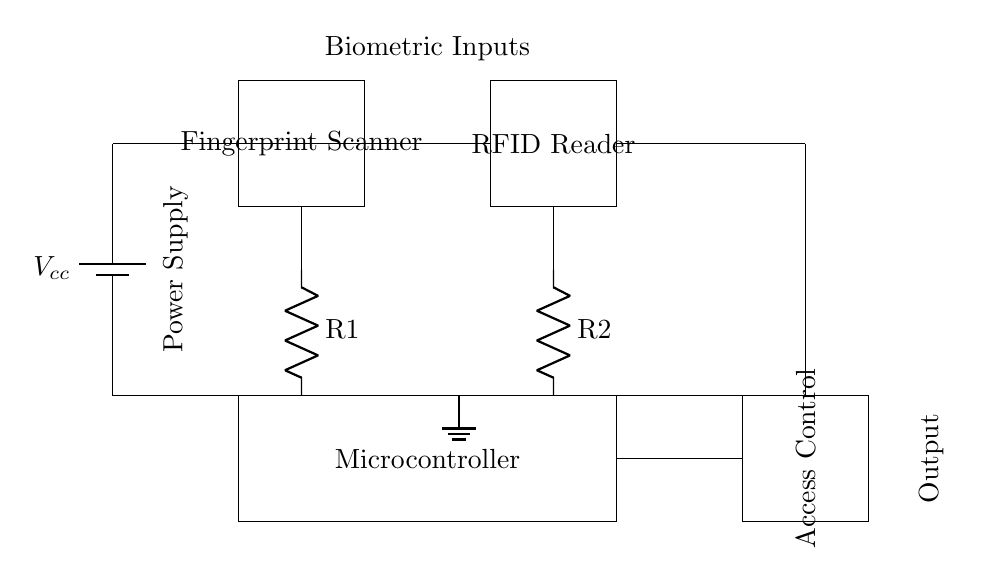What is the power source of the circuit? The power source is denoted as Vcc, which stands for the supply voltage for the circuit. It is shown at the top left of the diagram providing power to the components.
Answer: Vcc What two biometric inputs are present in the circuit? The two biometric inputs indicated in the diagram are the Fingerprint Scanner and the RFID Reader, both of which are represented as distinct rectangular blocks.
Answer: Fingerprint Scanner and RFID Reader What type of component is the Access Control? The Access Control is represented by a rectangular block labeled as such in the diagram, indicating it serves as the output stage for controlling access based on biometric inputs.
Answer: Output How many resistors are shown in the circuit? The circuit diagram includes two resistors identified by R1 and R2, connected to the outputs of the Fingerprint Scanner and RFID Reader, respectively.
Answer: Two What is the primary function of the Microcontroller in this circuit? The Microcontroller processes the signals from both biometric devices (Fingerprint Scanner and RFID Reader) to determine access rights, acting as the decision-making unit that integrates both inputs.
Answer: Decision making What are the connections from both biometric inputs to the Microcontroller? The connections are illustrated by lines leading from the lower part of each biometric device (Fingerprint Scanner and RFID Reader) downward to the Microcontroller, which signifies they provide input signals to it.
Answer: Input connections Which component provides ground reference for the circuit? The ground reference is symbolized by the ground symbol located at the bottom center of the circuit, indicating the common return path for the current in the system.
Answer: Ground 